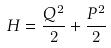Convert formula to latex. <formula><loc_0><loc_0><loc_500><loc_500>H = \frac { Q ^ { 2 } } { 2 } + \frac { P ^ { 2 } } { 2 }</formula> 